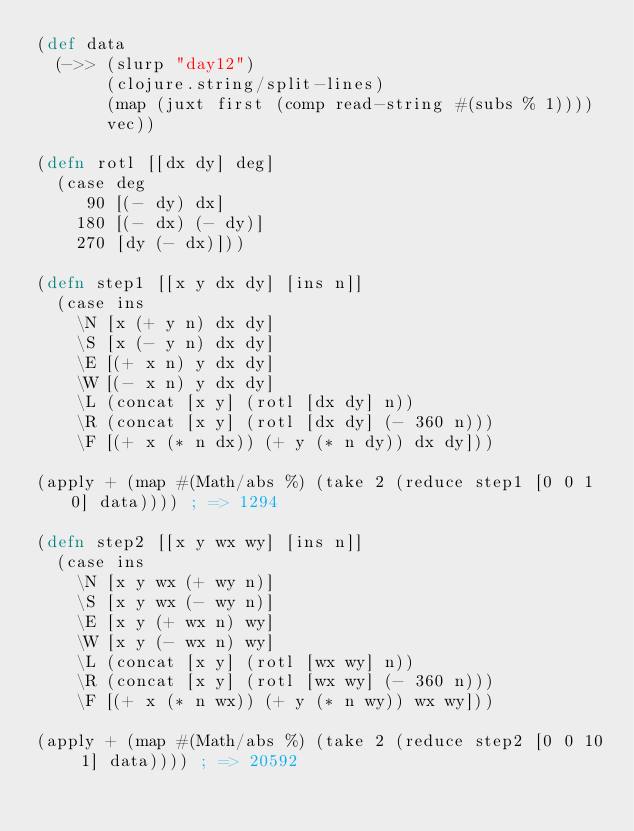<code> <loc_0><loc_0><loc_500><loc_500><_Clojure_>(def data
  (->> (slurp "day12")
       (clojure.string/split-lines)
       (map (juxt first (comp read-string #(subs % 1))))
       vec))

(defn rotl [[dx dy] deg]
  (case deg
     90 [(- dy) dx]
    180 [(- dx) (- dy)]
    270 [dy (- dx)]))

(defn step1 [[x y dx dy] [ins n]]
  (case ins
    \N [x (+ y n) dx dy]
    \S [x (- y n) dx dy]
    \E [(+ x n) y dx dy]
    \W [(- x n) y dx dy]
    \L (concat [x y] (rotl [dx dy] n))
    \R (concat [x y] (rotl [dx dy] (- 360 n)))    
    \F [(+ x (* n dx)) (+ y (* n dy)) dx dy]))

(apply + (map #(Math/abs %) (take 2 (reduce step1 [0 0 1 0] data)))) ; => 1294

(defn step2 [[x y wx wy] [ins n]]
  (case ins
    \N [x y wx (+ wy n)]
    \S [x y wx (- wy n)]
    \E [x y (+ wx n) wy]
    \W [x y (- wx n) wy]
    \L (concat [x y] (rotl [wx wy] n))
    \R (concat [x y] (rotl [wx wy] (- 360 n)))
    \F [(+ x (* n wx)) (+ y (* n wy)) wx wy]))

(apply + (map #(Math/abs %) (take 2 (reduce step2 [0 0 10 1] data)))) ; => 20592
</code> 